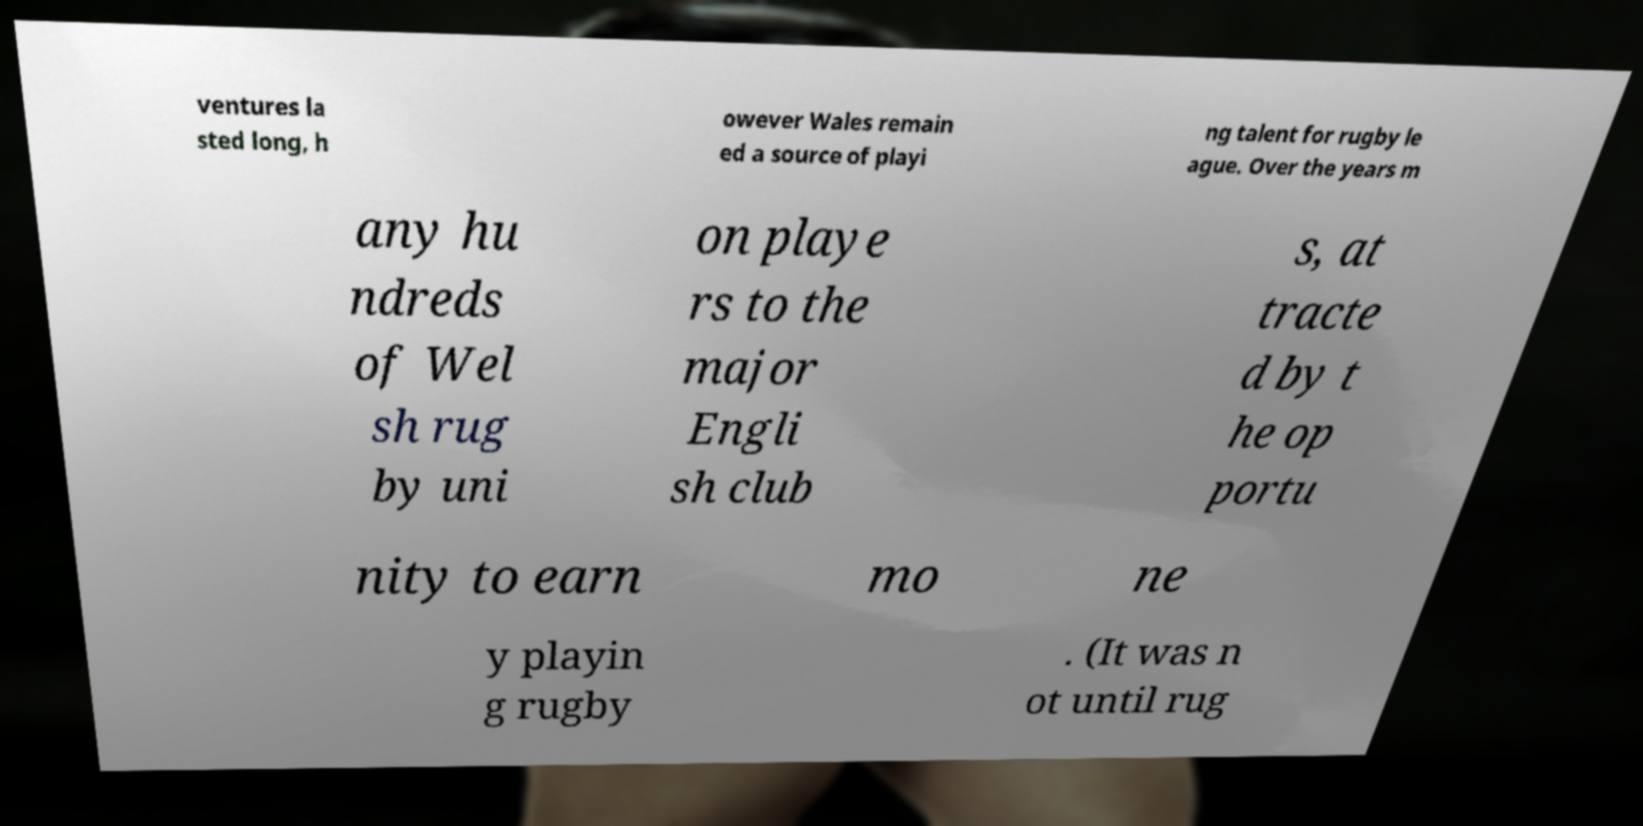What messages or text are displayed in this image? I need them in a readable, typed format. ventures la sted long, h owever Wales remain ed a source of playi ng talent for rugby le ague. Over the years m any hu ndreds of Wel sh rug by uni on playe rs to the major Engli sh club s, at tracte d by t he op portu nity to earn mo ne y playin g rugby . (It was n ot until rug 